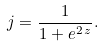Convert formula to latex. <formula><loc_0><loc_0><loc_500><loc_500>j = \frac { 1 } { 1 + e ^ { 2 \, z } } .</formula> 